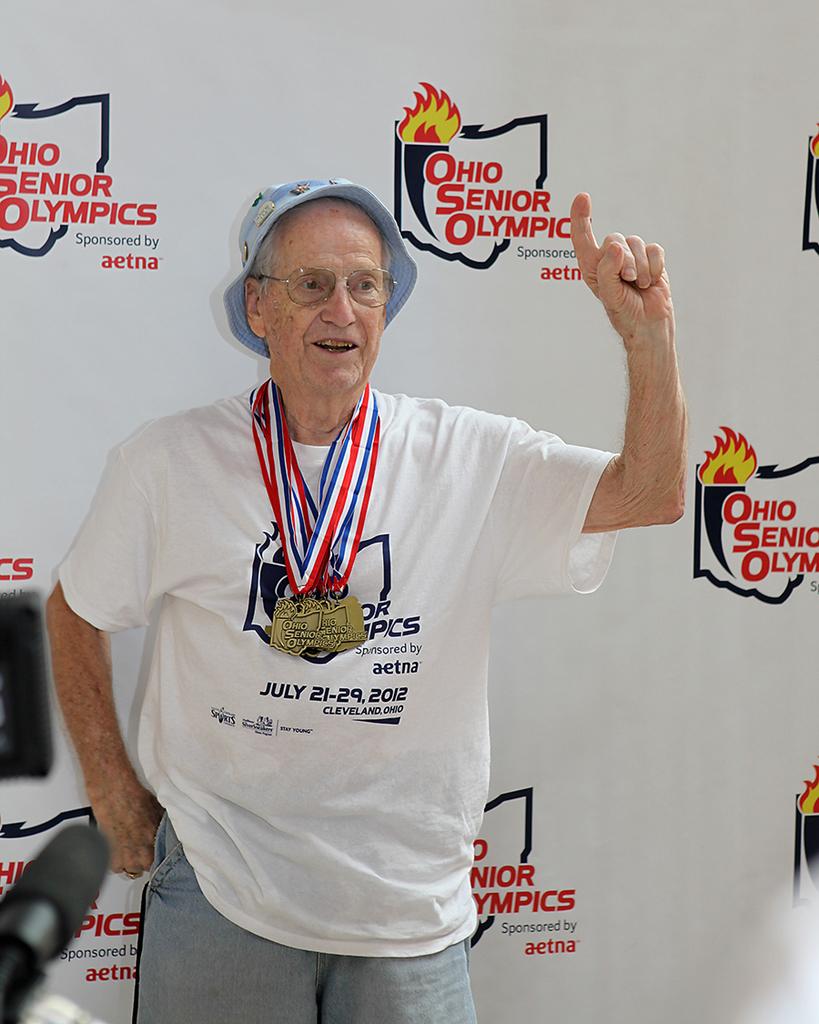How's is the event called?
Your answer should be compact. Ohio senior olympics. What year does the man's shirt say this event took place in?
Provide a succinct answer. 2012. 